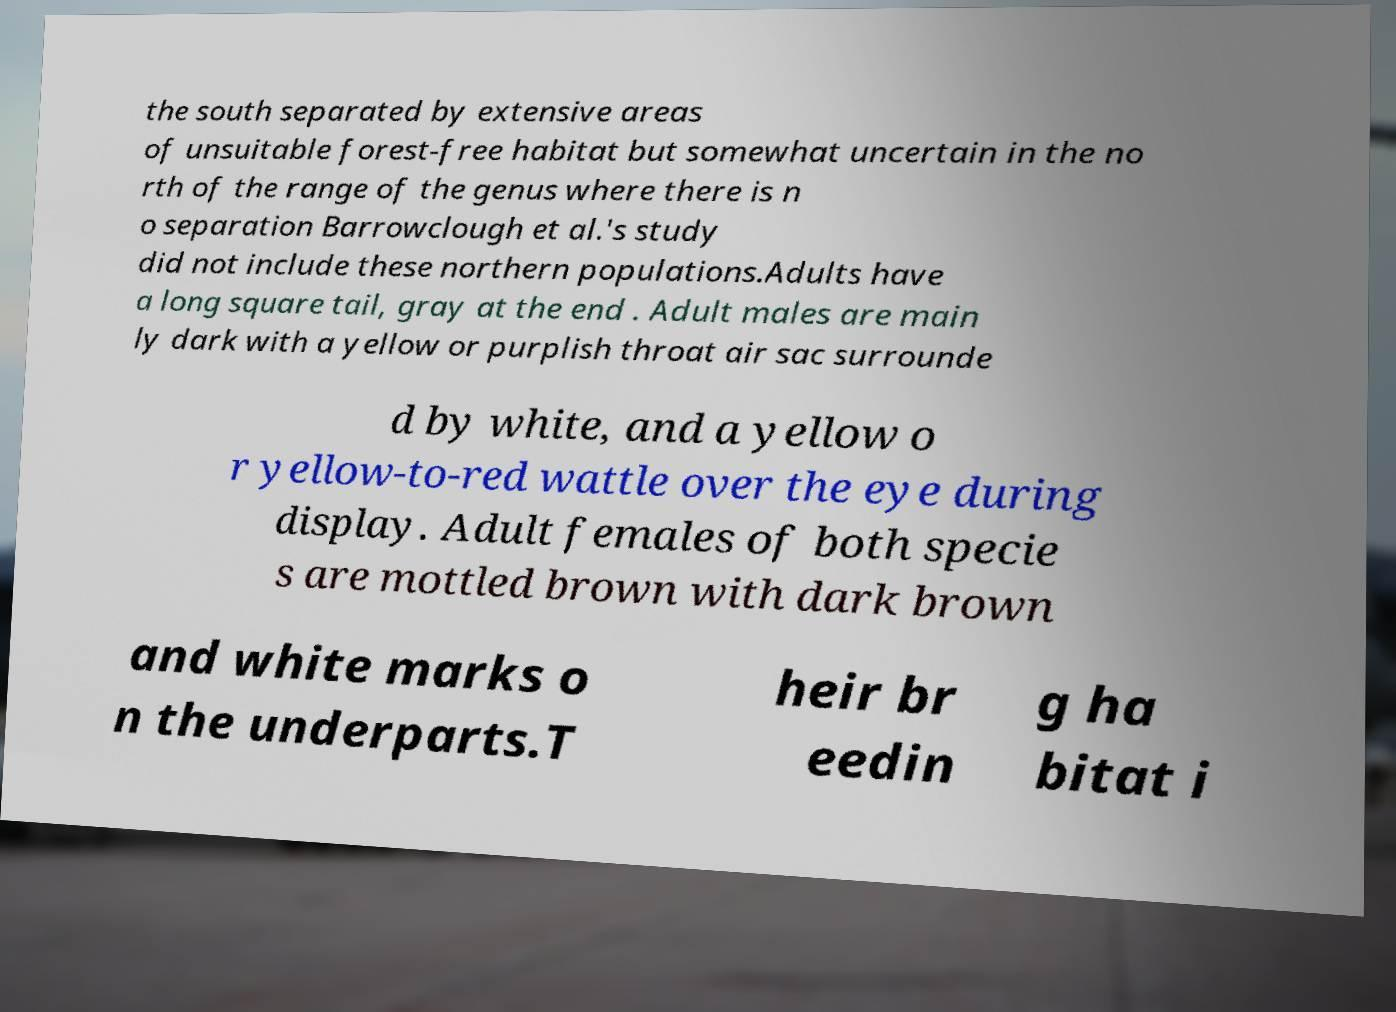What messages or text are displayed in this image? I need them in a readable, typed format. the south separated by extensive areas of unsuitable forest-free habitat but somewhat uncertain in the no rth of the range of the genus where there is n o separation Barrowclough et al.'s study did not include these northern populations.Adults have a long square tail, gray at the end . Adult males are main ly dark with a yellow or purplish throat air sac surrounde d by white, and a yellow o r yellow-to-red wattle over the eye during display. Adult females of both specie s are mottled brown with dark brown and white marks o n the underparts.T heir br eedin g ha bitat i 